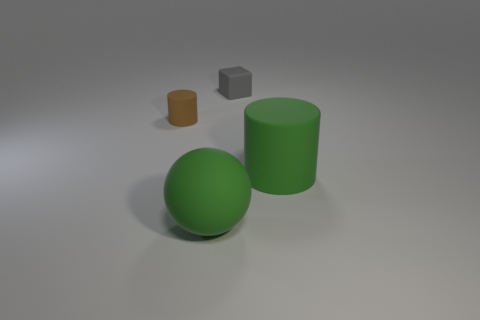Add 4 tiny gray matte things. How many objects exist? 8 Subtract all blocks. How many objects are left? 3 Subtract 1 green cylinders. How many objects are left? 3 Subtract all matte balls. Subtract all balls. How many objects are left? 2 Add 1 gray blocks. How many gray blocks are left? 2 Add 2 large red cylinders. How many large red cylinders exist? 2 